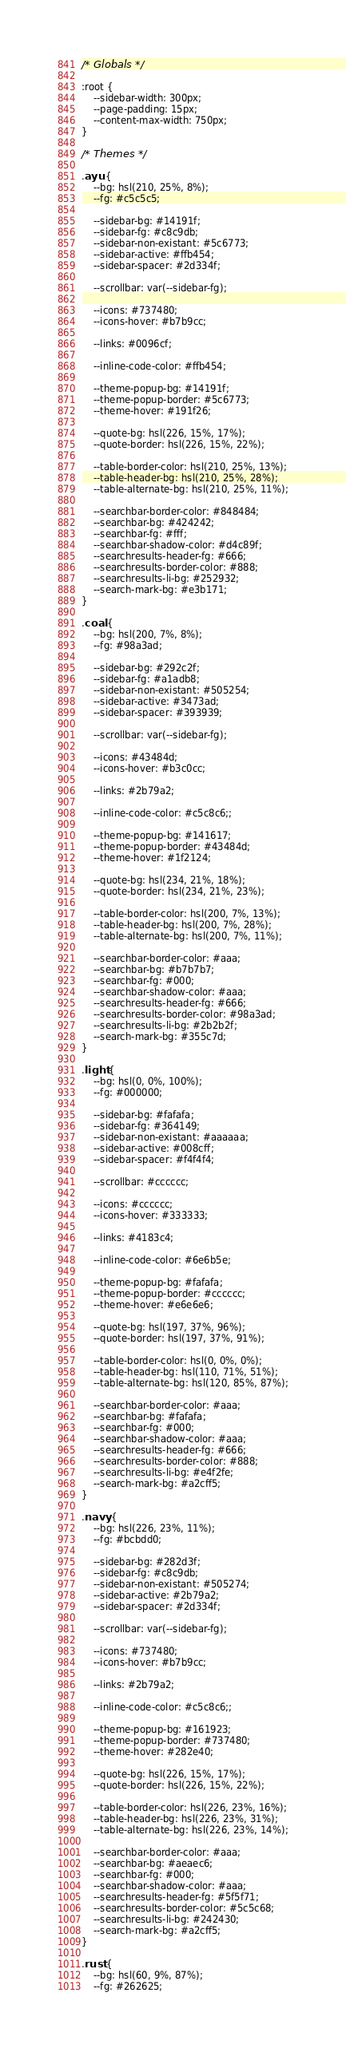Convert code to text. <code><loc_0><loc_0><loc_500><loc_500><_CSS_>
/* Globals */

:root {
    --sidebar-width: 300px;
    --page-padding: 15px;
    --content-max-width: 750px;
}

/* Themes */

.ayu {
    --bg: hsl(210, 25%, 8%);
    --fg: #c5c5c5;

    --sidebar-bg: #14191f;
    --sidebar-fg: #c8c9db;
    --sidebar-non-existant: #5c6773;
    --sidebar-active: #ffb454;
    --sidebar-spacer: #2d334f;

    --scrollbar: var(--sidebar-fg);

    --icons: #737480;
    --icons-hover: #b7b9cc;

    --links: #0096cf;

    --inline-code-color: #ffb454;

    --theme-popup-bg: #14191f;
    --theme-popup-border: #5c6773;
    --theme-hover: #191f26;

    --quote-bg: hsl(226, 15%, 17%);
    --quote-border: hsl(226, 15%, 22%);

    --table-border-color: hsl(210, 25%, 13%);
    --table-header-bg: hsl(210, 25%, 28%);
    --table-alternate-bg: hsl(210, 25%, 11%);

    --searchbar-border-color: #848484;
    --searchbar-bg: #424242;
    --searchbar-fg: #fff;
    --searchbar-shadow-color: #d4c89f;
    --searchresults-header-fg: #666;
    --searchresults-border-color: #888;
    --searchresults-li-bg: #252932;
    --search-mark-bg: #e3b171;
}

.coal {
    --bg: hsl(200, 7%, 8%);
    --fg: #98a3ad;

    --sidebar-bg: #292c2f;
    --sidebar-fg: #a1adb8;
    --sidebar-non-existant: #505254;
    --sidebar-active: #3473ad;
    --sidebar-spacer: #393939;

    --scrollbar: var(--sidebar-fg);

    --icons: #43484d;
    --icons-hover: #b3c0cc;

    --links: #2b79a2;

    --inline-code-color: #c5c8c6;;

    --theme-popup-bg: #141617;
    --theme-popup-border: #43484d;
    --theme-hover: #1f2124;

    --quote-bg: hsl(234, 21%, 18%);
    --quote-border: hsl(234, 21%, 23%);

    --table-border-color: hsl(200, 7%, 13%);
    --table-header-bg: hsl(200, 7%, 28%);
    --table-alternate-bg: hsl(200, 7%, 11%);

    --searchbar-border-color: #aaa;
    --searchbar-bg: #b7b7b7;
    --searchbar-fg: #000;
    --searchbar-shadow-color: #aaa;
    --searchresults-header-fg: #666;
    --searchresults-border-color: #98a3ad;
    --searchresults-li-bg: #2b2b2f;
    --search-mark-bg: #355c7d;
}

.light {
    --bg: hsl(0, 0%, 100%);
    --fg: #000000;

    --sidebar-bg: #fafafa;
    --sidebar-fg: #364149;
    --sidebar-non-existant: #aaaaaa;
    --sidebar-active: #008cff;
    --sidebar-spacer: #f4f4f4;

    --scrollbar: #cccccc;

    --icons: #cccccc;
    --icons-hover: #333333;

    --links: #4183c4;

    --inline-code-color: #6e6b5e;

    --theme-popup-bg: #fafafa;
    --theme-popup-border: #cccccc;
    --theme-hover: #e6e6e6;

    --quote-bg: hsl(197, 37%, 96%);
    --quote-border: hsl(197, 37%, 91%);

    --table-border-color: hsl(0, 0%, 0%);
    --table-header-bg: hsl(110, 71%, 51%);
    --table-alternate-bg: hsl(120, 85%, 87%);

    --searchbar-border-color: #aaa;
    --searchbar-bg: #fafafa;
    --searchbar-fg: #000;
    --searchbar-shadow-color: #aaa;
    --searchresults-header-fg: #666;
    --searchresults-border-color: #888;
    --searchresults-li-bg: #e4f2fe;
    --search-mark-bg: #a2cff5;
}

.navy {
    --bg: hsl(226, 23%, 11%);
    --fg: #bcbdd0;

    --sidebar-bg: #282d3f;
    --sidebar-fg: #c8c9db;
    --sidebar-non-existant: #505274;
    --sidebar-active: #2b79a2;
    --sidebar-spacer: #2d334f;

    --scrollbar: var(--sidebar-fg);

    --icons: #737480;
    --icons-hover: #b7b9cc;

    --links: #2b79a2;

    --inline-code-color: #c5c8c6;;

    --theme-popup-bg: #161923;
    --theme-popup-border: #737480;
    --theme-hover: #282e40;

    --quote-bg: hsl(226, 15%, 17%);
    --quote-border: hsl(226, 15%, 22%);

    --table-border-color: hsl(226, 23%, 16%);
    --table-header-bg: hsl(226, 23%, 31%);
    --table-alternate-bg: hsl(226, 23%, 14%);

    --searchbar-border-color: #aaa;
    --searchbar-bg: #aeaec6;
    --searchbar-fg: #000;
    --searchbar-shadow-color: #aaa;
    --searchresults-header-fg: #5f5f71;
    --searchresults-border-color: #5c5c68;
    --searchresults-li-bg: #242430;
    --search-mark-bg: #a2cff5;
}

.rust {
    --bg: hsl(60, 9%, 87%);
    --fg: #262625;
</code> 